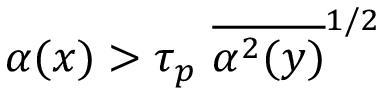<formula> <loc_0><loc_0><loc_500><loc_500>\alpha ( x ) > \tau _ { p } \, \overline { { \alpha ^ { 2 } ( y ) } } ^ { 1 / 2 }</formula> 